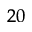<formula> <loc_0><loc_0><loc_500><loc_500>_ { 2 0 }</formula> 